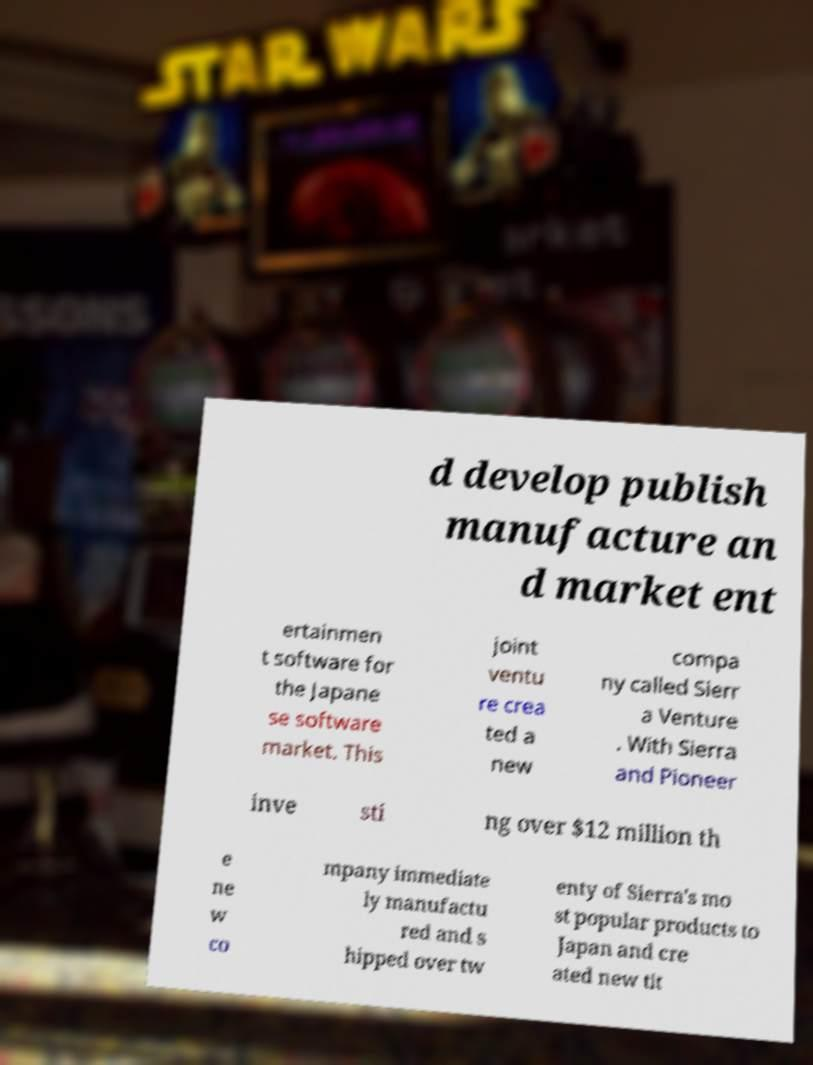Could you assist in decoding the text presented in this image and type it out clearly? d develop publish manufacture an d market ent ertainmen t software for the Japane se software market. This joint ventu re crea ted a new compa ny called Sierr a Venture . With Sierra and Pioneer inve sti ng over $12 million th e ne w co mpany immediate ly manufactu red and s hipped over tw enty of Sierra's mo st popular products to Japan and cre ated new tit 